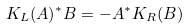<formula> <loc_0><loc_0><loc_500><loc_500>K _ { L } ( A ) ^ { * } B = - A ^ { * } K _ { R } ( B )</formula> 